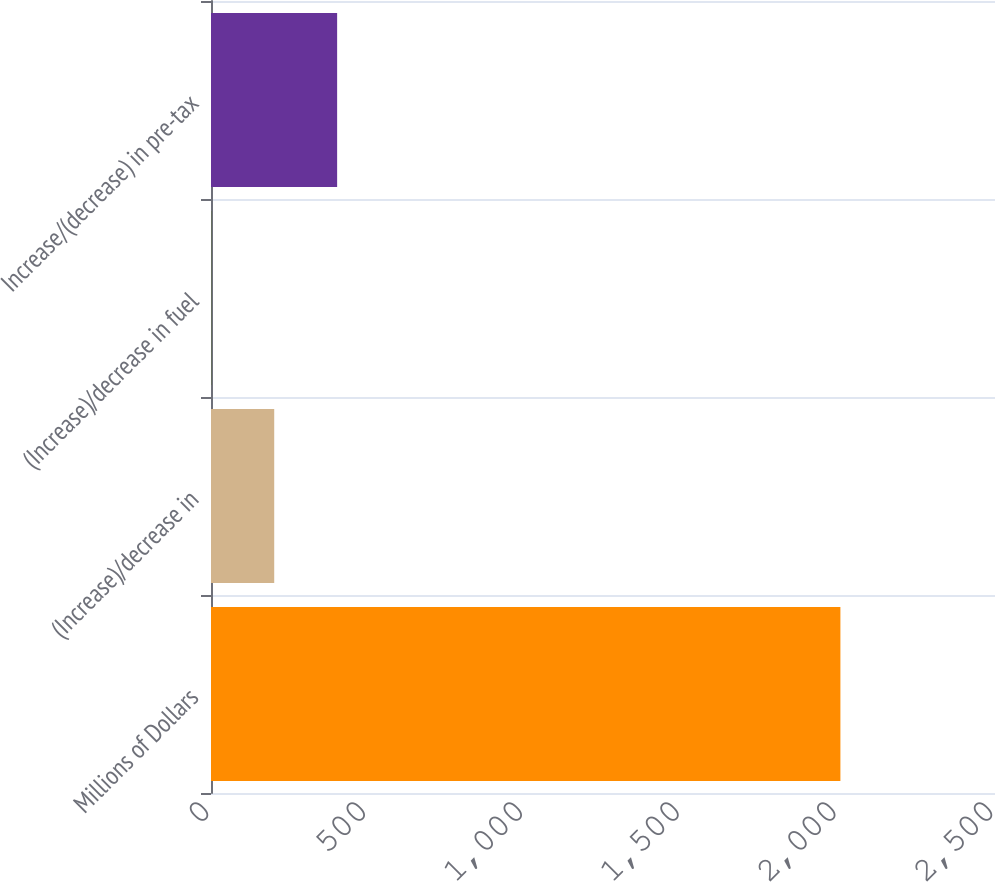<chart> <loc_0><loc_0><loc_500><loc_500><bar_chart><fcel>Millions of Dollars<fcel>(Increase)/decrease in<fcel>(Increase)/decrease in fuel<fcel>Increase/(decrease) in pre-tax<nl><fcel>2007<fcel>201.6<fcel>1<fcel>402.2<nl></chart> 